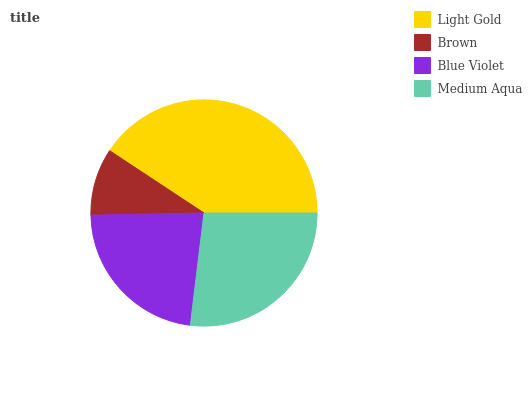Is Brown the minimum?
Answer yes or no. Yes. Is Light Gold the maximum?
Answer yes or no. Yes. Is Blue Violet the minimum?
Answer yes or no. No. Is Blue Violet the maximum?
Answer yes or no. No. Is Blue Violet greater than Brown?
Answer yes or no. Yes. Is Brown less than Blue Violet?
Answer yes or no. Yes. Is Brown greater than Blue Violet?
Answer yes or no. No. Is Blue Violet less than Brown?
Answer yes or no. No. Is Medium Aqua the high median?
Answer yes or no. Yes. Is Blue Violet the low median?
Answer yes or no. Yes. Is Light Gold the high median?
Answer yes or no. No. Is Medium Aqua the low median?
Answer yes or no. No. 